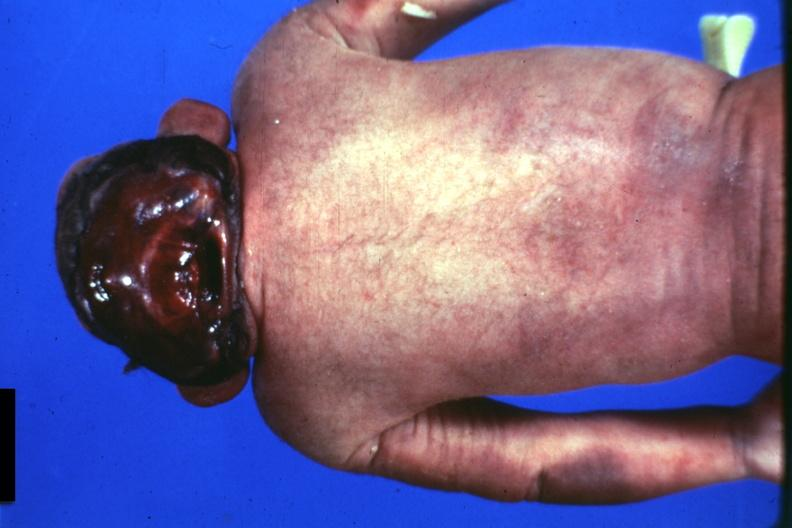what does this image show?
Answer the question using a single word or phrase. Posterior view of typical case 